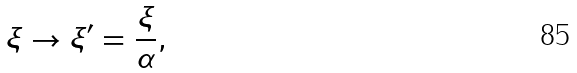Convert formula to latex. <formula><loc_0><loc_0><loc_500><loc_500>\xi \rightarrow \xi ^ { \prime } = \frac { \xi } { \alpha } ,</formula> 